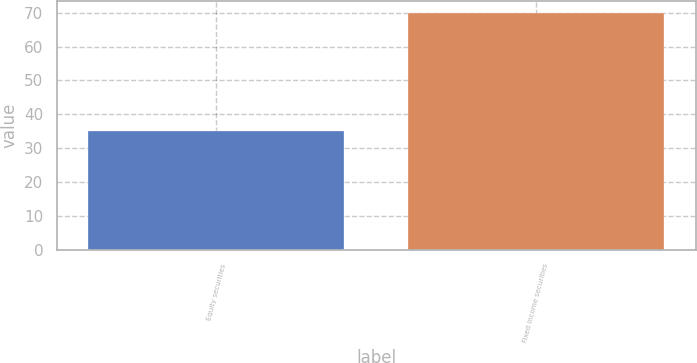<chart> <loc_0><loc_0><loc_500><loc_500><bar_chart><fcel>Equity securities<fcel>Fixed income securities<nl><fcel>35<fcel>70<nl></chart> 